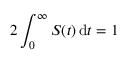<formula> <loc_0><loc_0><loc_500><loc_500>2 \int _ { 0 } ^ { \infty } S ( t ) \, d t = 1</formula> 